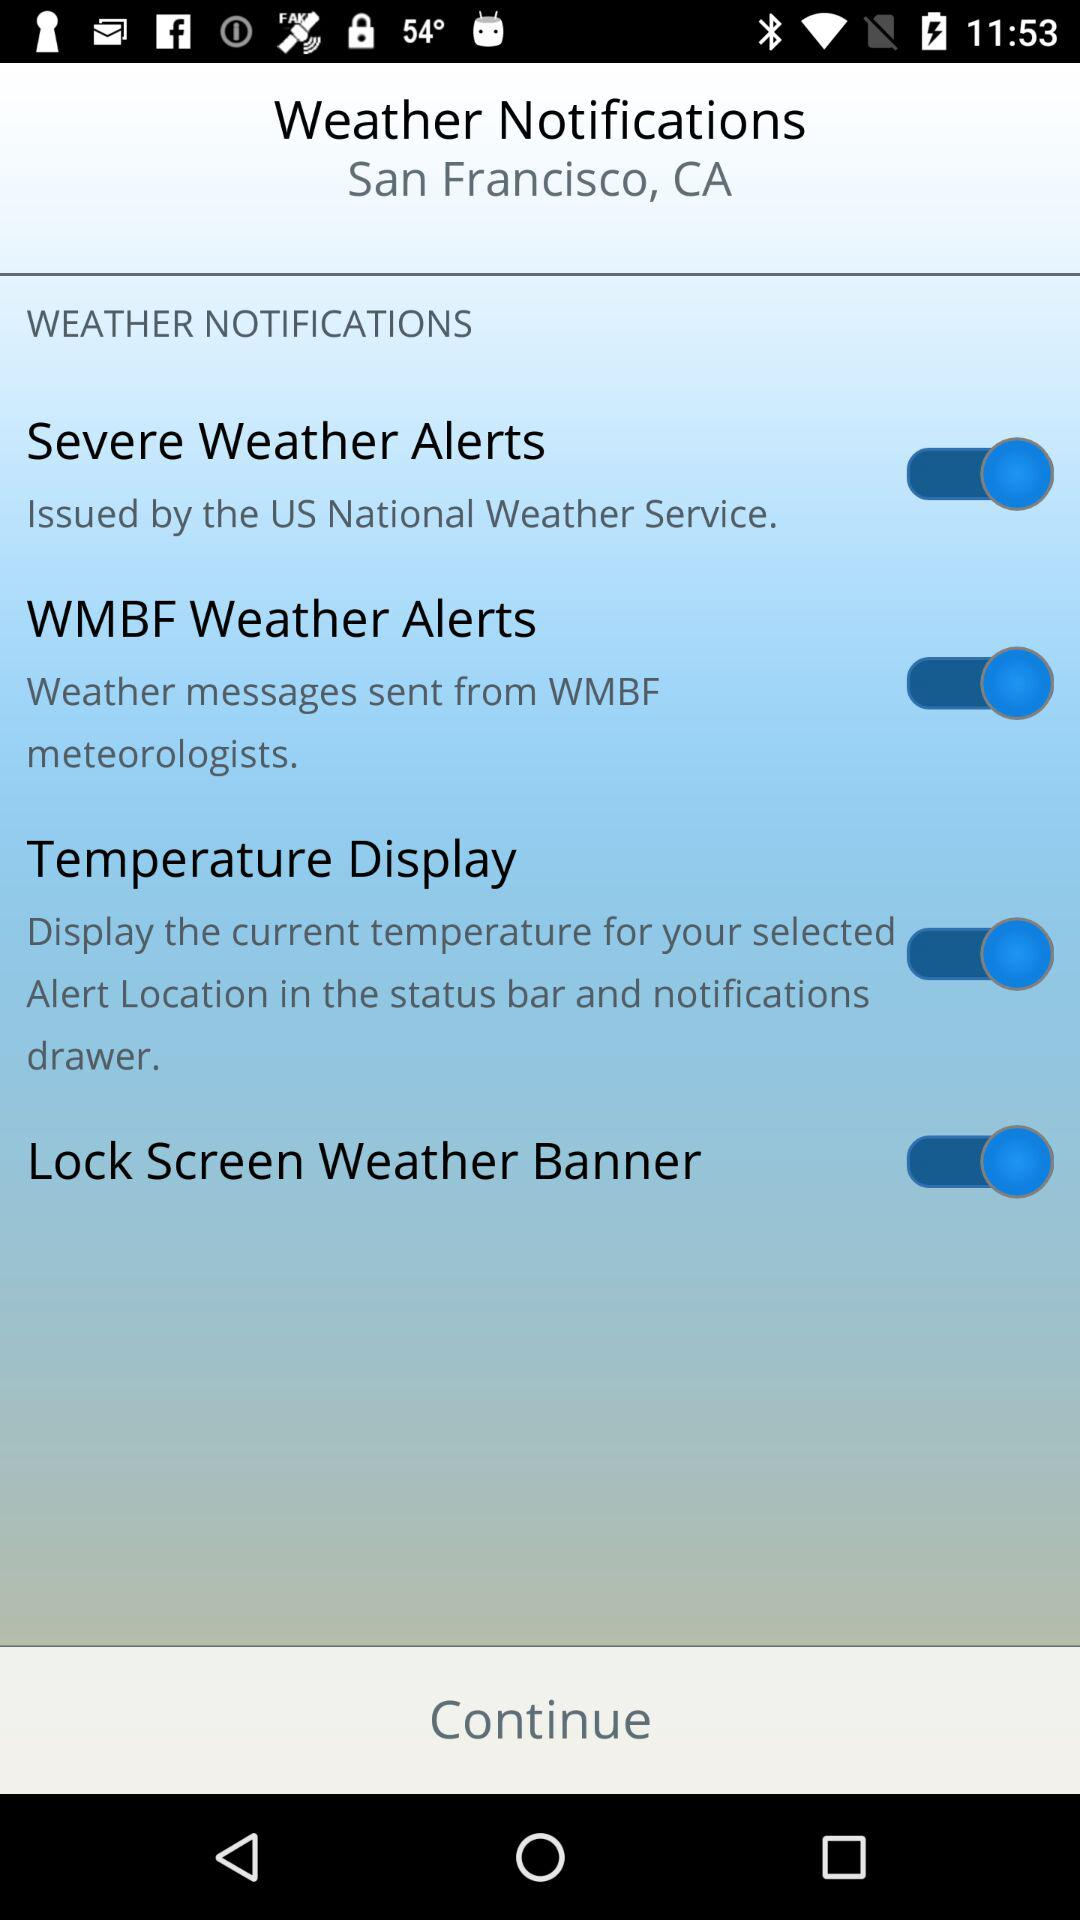What is the location? The location is San Francisco, CA. 